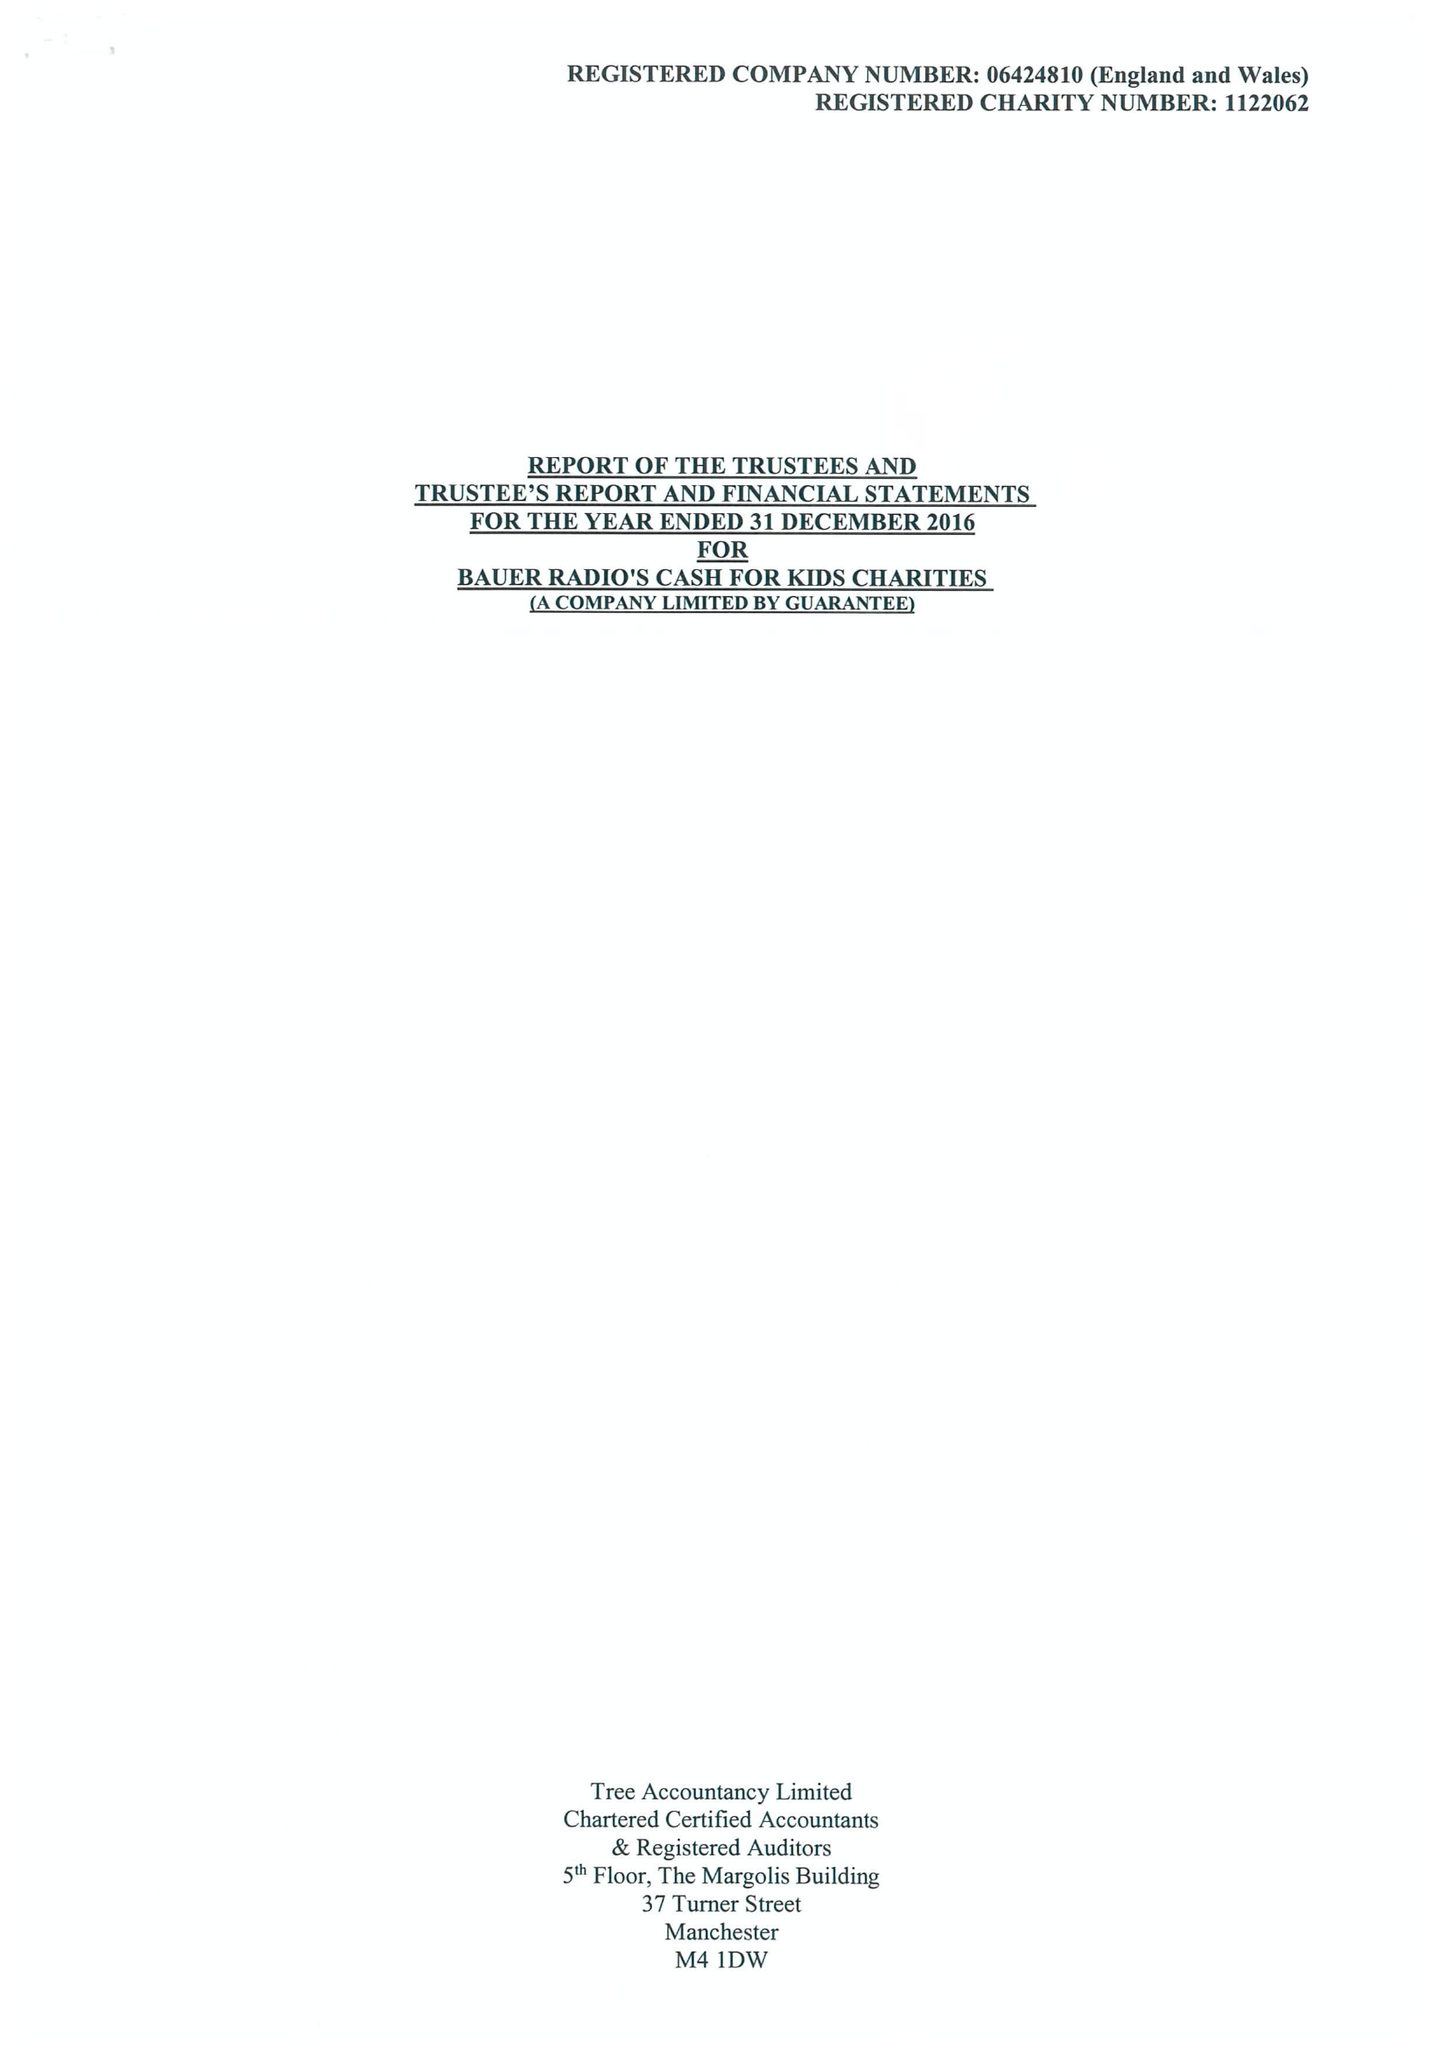What is the value for the charity_name?
Answer the question using a single word or phrase. Bauer Radio's Cash For Kids Charities 